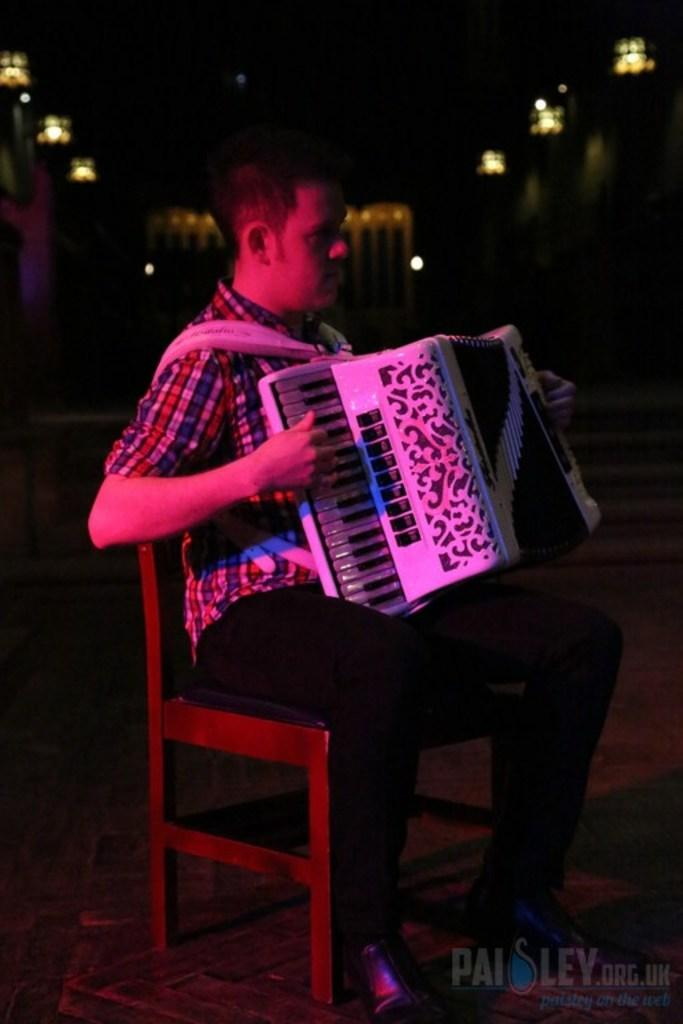What is the main subject of the image? There is a man in the image. What is the man doing in the image? The man is sitting on a chair and playing a musical instrument. How can you describe the background of the image? The background of the image is dark. What else can be seen in the image besides the man and his activity? There are lights visible on the ceiling. What type of tin can be seen on the man's toes in the image? There is no tin or any reference to the man's toes in the image. What kind of spark can be seen coming from the musical instrument in the image? There is no spark visible in the image; the man is simply playing the musical instrument. 